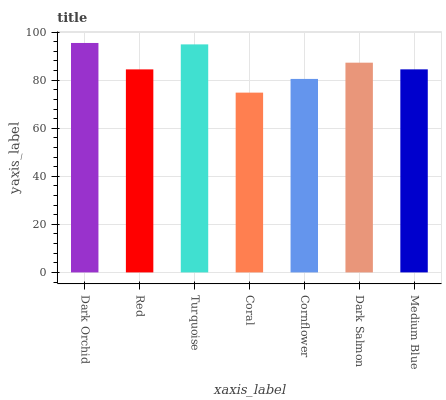Is Coral the minimum?
Answer yes or no. Yes. Is Dark Orchid the maximum?
Answer yes or no. Yes. Is Red the minimum?
Answer yes or no. No. Is Red the maximum?
Answer yes or no. No. Is Dark Orchid greater than Red?
Answer yes or no. Yes. Is Red less than Dark Orchid?
Answer yes or no. Yes. Is Red greater than Dark Orchid?
Answer yes or no. No. Is Dark Orchid less than Red?
Answer yes or no. No. Is Medium Blue the high median?
Answer yes or no. Yes. Is Medium Blue the low median?
Answer yes or no. Yes. Is Red the high median?
Answer yes or no. No. Is Dark Orchid the low median?
Answer yes or no. No. 